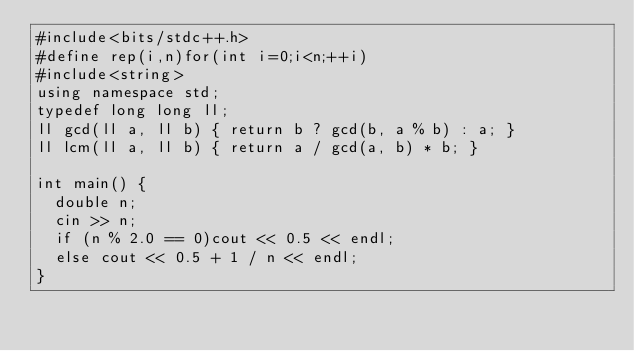<code> <loc_0><loc_0><loc_500><loc_500><_C++_>#include<bits/stdc++.h>
#define rep(i,n)for(int i=0;i<n;++i)
#include<string>
using namespace std;
typedef long long ll;
ll gcd(ll a, ll b) { return b ? gcd(b, a % b) : a; }
ll lcm(ll a, ll b) { return a / gcd(a, b) * b; }

int main() {
	double n;
	cin >> n;
	if (n % 2.0 == 0)cout << 0.5 << endl;
	else cout << 0.5 + 1 / n << endl;
}</code> 